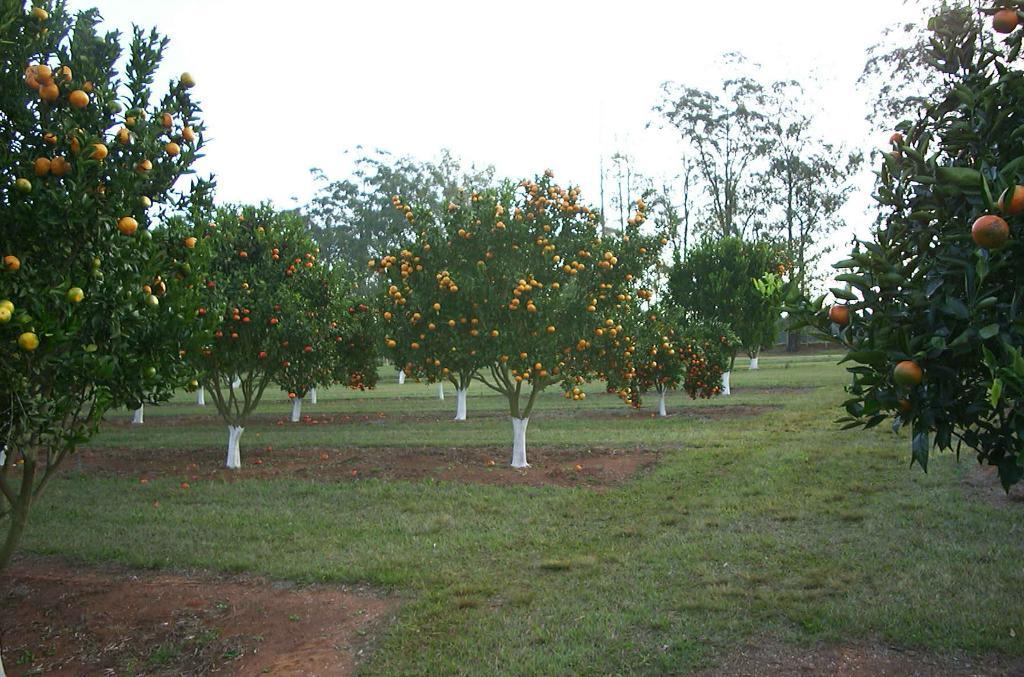What type of vegetation is present in the image? There are trees with fruits in the image. What can be seen at the bottom of the image? The ground is visible at the bottom of the image. What is visible at the top of the image? The sky is visible at the top of the image. What type of shirt is the tree wearing in the image? Trees do not wear shirts, so this question cannot be answered. 